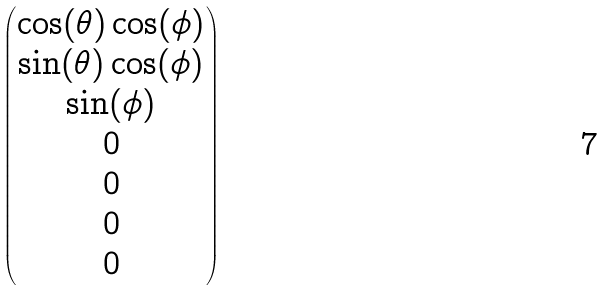Convert formula to latex. <formula><loc_0><loc_0><loc_500><loc_500>\begin{pmatrix} \cos ( \theta ) \cos ( \phi ) \\ \sin ( \theta ) \cos ( \phi ) \\ \sin ( \phi ) \\ 0 \\ 0 \\ 0 \\ 0 \end{pmatrix}</formula> 